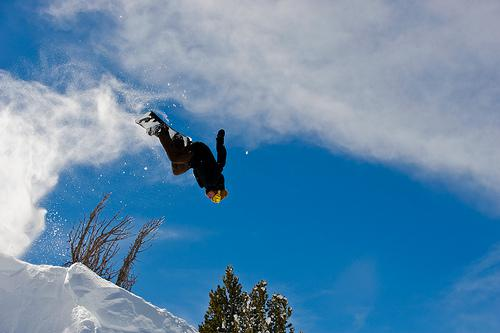Question: how is the weather?
Choices:
A. Rainy.
B. Sunny and clear.
C. Snowy.
D. Overcast.
Answer with the letter. Answer: B Question: why is the person in the air?
Choices:
A. On a plane.
B. Jumped off hill.
C. Parasailing.
D. Skydiving.
Answer with the letter. Answer: B Question: where is the person located?
Choices:
A. On the ground.
B. In the air.
C. On a chair.
D. On the bed.
Answer with the letter. Answer: B Question: what color are the goggles?
Choices:
A. Blue.
B. White.
C. Black.
D. Yellow.
Answer with the letter. Answer: D Question: what is in the sky?
Choices:
A. Stars.
B. Constellations.
C. The moon.
D. Clouds.
Answer with the letter. Answer: D Question: where was the photo taken?
Choices:
A. Snowy area.
B. In the mountains.
C. On the beach.
D. In the forest.
Answer with the letter. Answer: A 